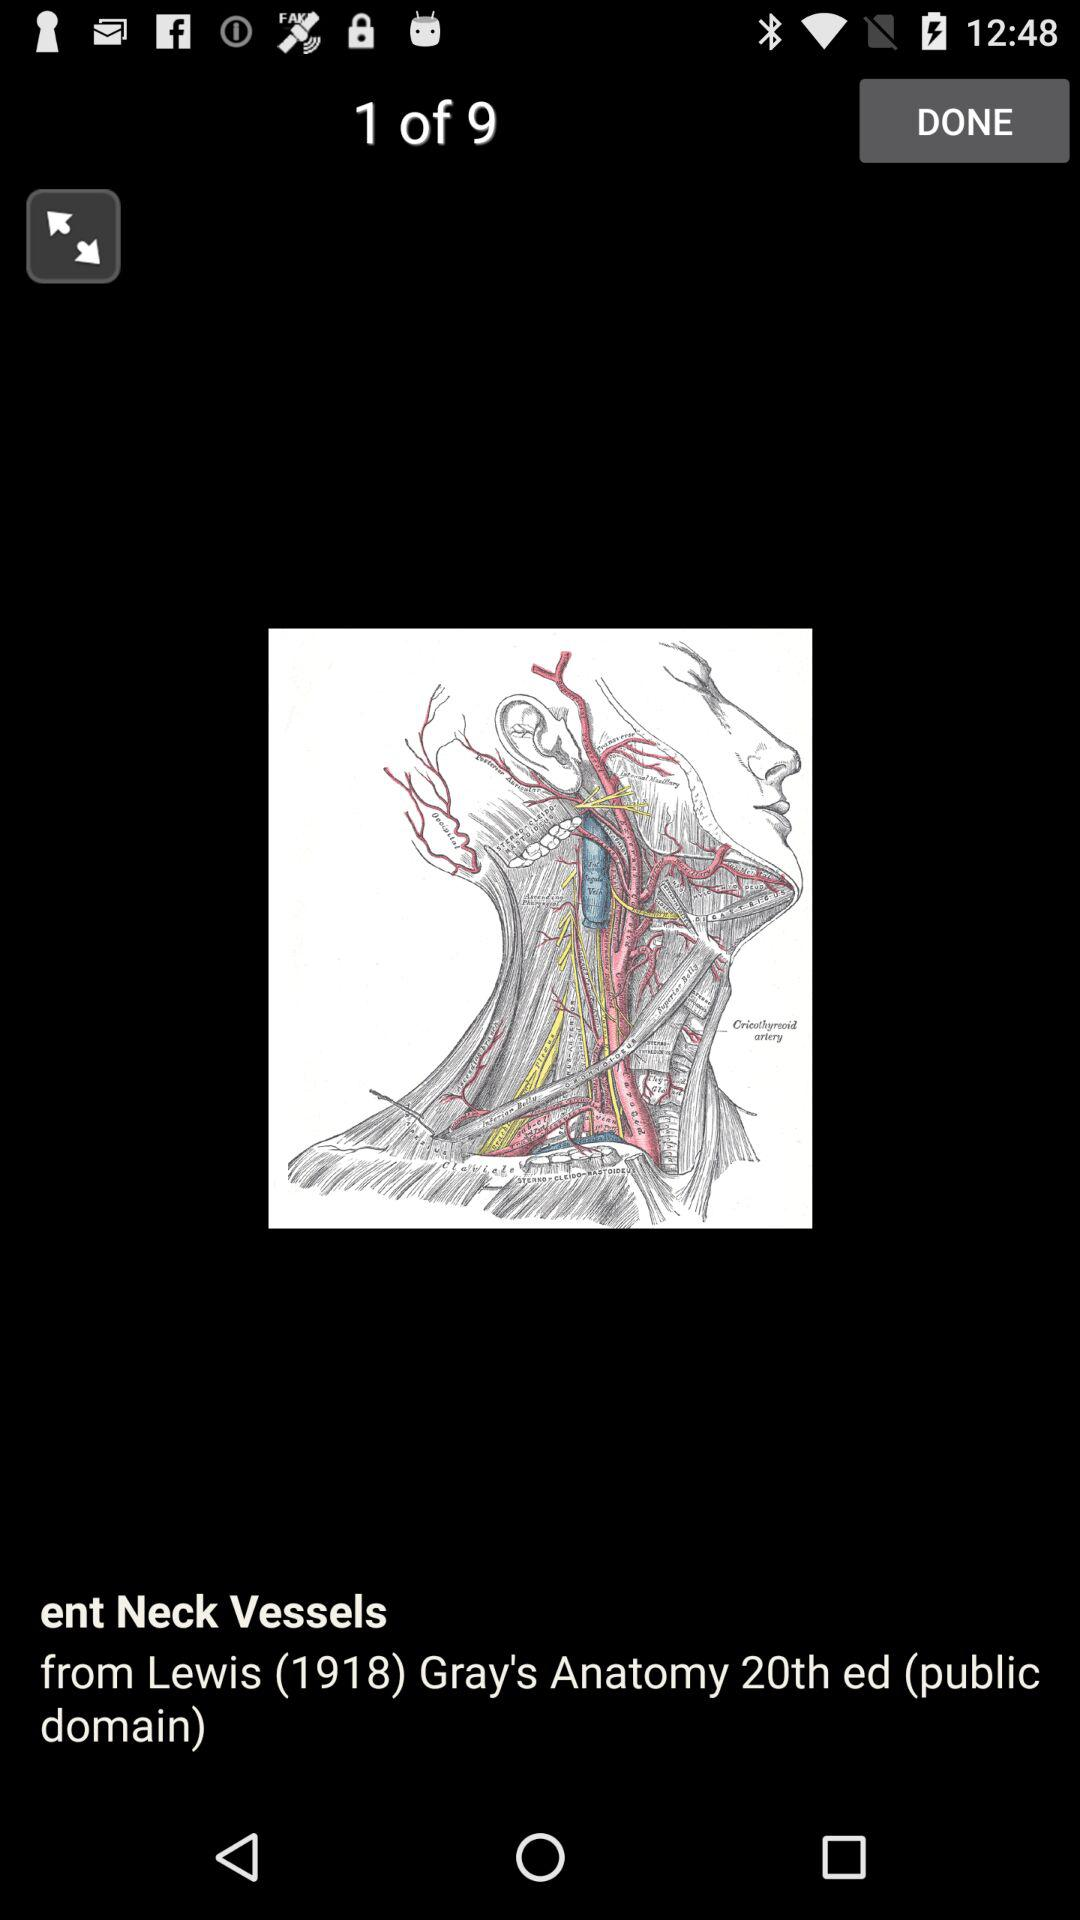What is the name of the image? The name of the image is "ent Neck Vessels". 